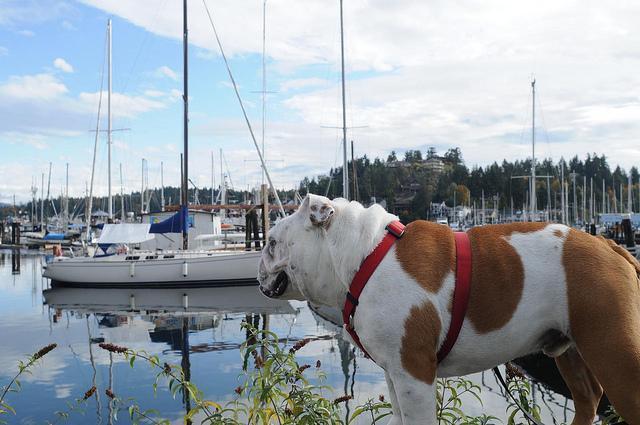How many horses so you see?
Give a very brief answer. 0. 